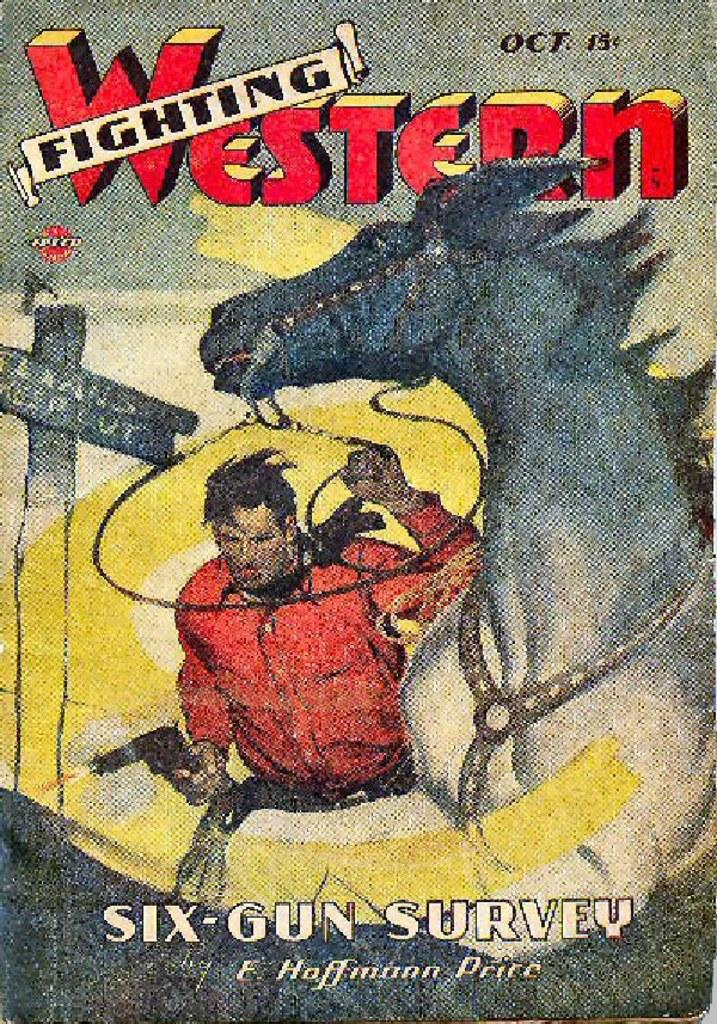<image>
Render a clear and concise summary of the photo. An October edition of the Fighting Western comic book series that cost 15 cents when it came out. 